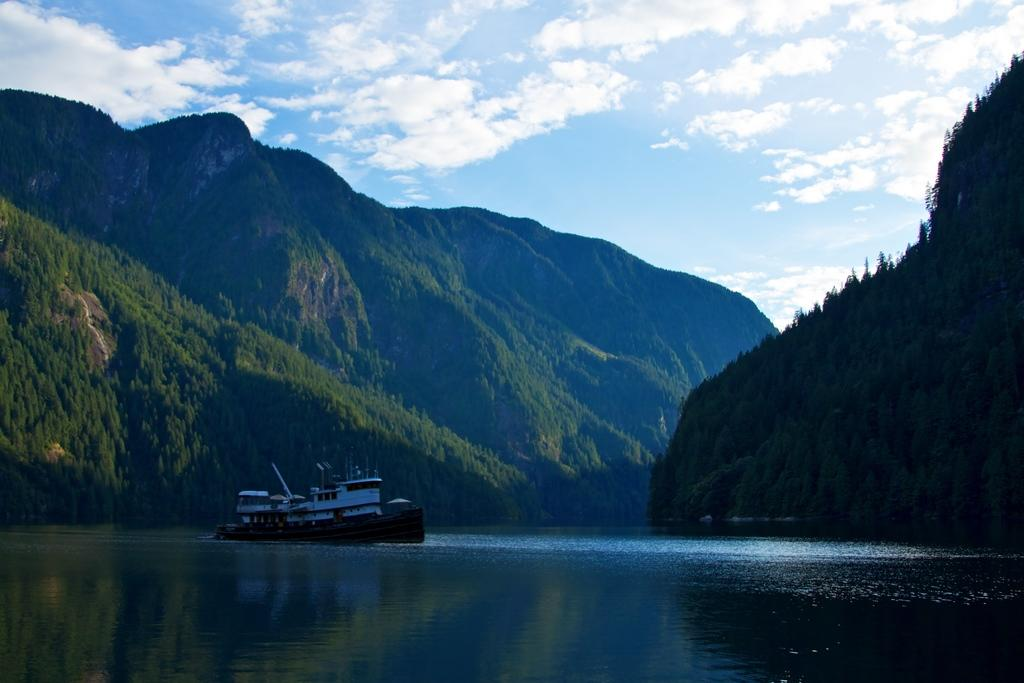What is the main subject of the image? The main subject of the image is a boat. Where is the boat located? The boat is on the water. What can be seen in the background of the image? There are mountains in the background of the image. What is the condition of the sky in the image? The sky is blue, and there are clouds visible. What type of zinc is being used to build the boat in the image? There is no mention of zinc or any building materials in the image; it simply shows a boat on the water. How many people are in the middle of the boat in the image? There is no indication of the number of people or their positions on the boat in the image. 